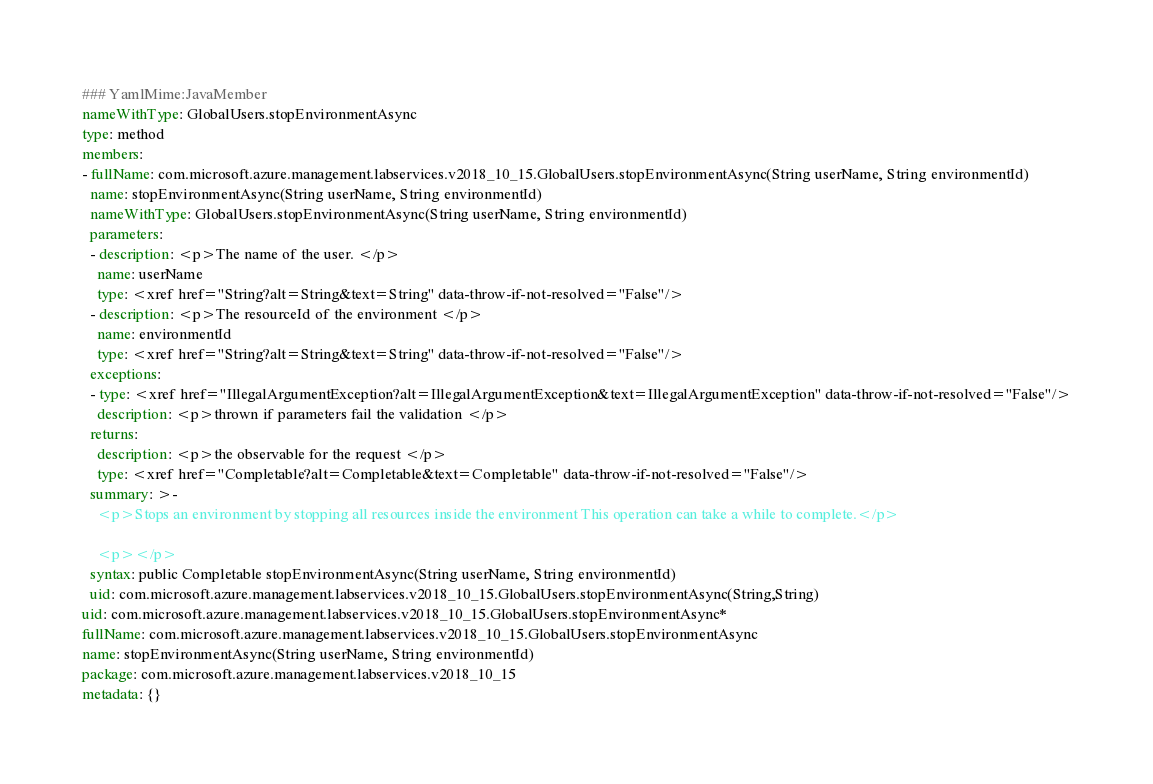Convert code to text. <code><loc_0><loc_0><loc_500><loc_500><_YAML_>### YamlMime:JavaMember
nameWithType: GlobalUsers.stopEnvironmentAsync
type: method
members:
- fullName: com.microsoft.azure.management.labservices.v2018_10_15.GlobalUsers.stopEnvironmentAsync(String userName, String environmentId)
  name: stopEnvironmentAsync(String userName, String environmentId)
  nameWithType: GlobalUsers.stopEnvironmentAsync(String userName, String environmentId)
  parameters:
  - description: <p>The name of the user. </p>
    name: userName
    type: <xref href="String?alt=String&text=String" data-throw-if-not-resolved="False"/>
  - description: <p>The resourceId of the environment </p>
    name: environmentId
    type: <xref href="String?alt=String&text=String" data-throw-if-not-resolved="False"/>
  exceptions:
  - type: <xref href="IllegalArgumentException?alt=IllegalArgumentException&text=IllegalArgumentException" data-throw-if-not-resolved="False"/>
    description: <p>thrown if parameters fail the validation </p>
  returns:
    description: <p>the observable for the request </p>
    type: <xref href="Completable?alt=Completable&text=Completable" data-throw-if-not-resolved="False"/>
  summary: >-
    <p>Stops an environment by stopping all resources inside the environment This operation can take a while to complete.</p>

    <p></p>
  syntax: public Completable stopEnvironmentAsync(String userName, String environmentId)
  uid: com.microsoft.azure.management.labservices.v2018_10_15.GlobalUsers.stopEnvironmentAsync(String,String)
uid: com.microsoft.azure.management.labservices.v2018_10_15.GlobalUsers.stopEnvironmentAsync*
fullName: com.microsoft.azure.management.labservices.v2018_10_15.GlobalUsers.stopEnvironmentAsync
name: stopEnvironmentAsync(String userName, String environmentId)
package: com.microsoft.azure.management.labservices.v2018_10_15
metadata: {}
</code> 